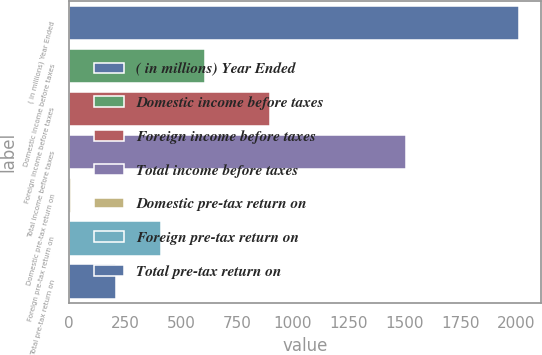Convert chart. <chart><loc_0><loc_0><loc_500><loc_500><bar_chart><fcel>( in millions) Year Ended<fcel>Domestic income before taxes<fcel>Foreign income before taxes<fcel>Total income before taxes<fcel>Domestic pre-tax return on<fcel>Foreign pre-tax return on<fcel>Total pre-tax return on<nl><fcel>2011<fcel>609.04<fcel>899.9<fcel>1506.9<fcel>8.2<fcel>408.76<fcel>208.48<nl></chart> 